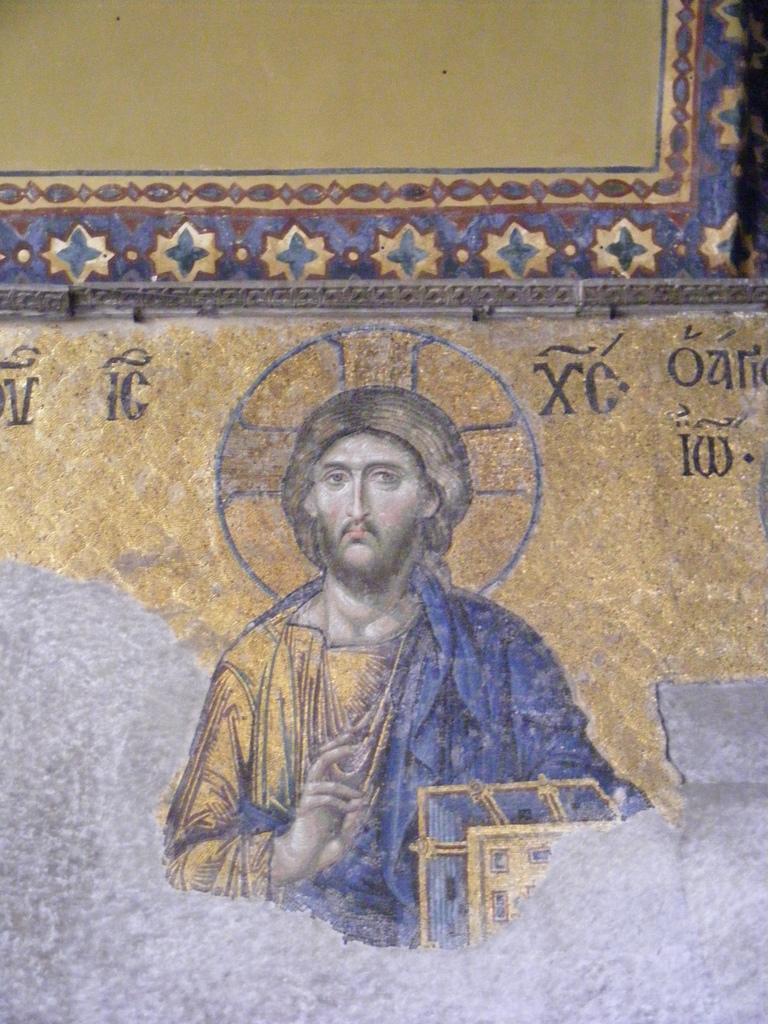Describe this image in one or two sentences. In this image we can see the painting of a person. We can also some design and also the text on the plain wall. 